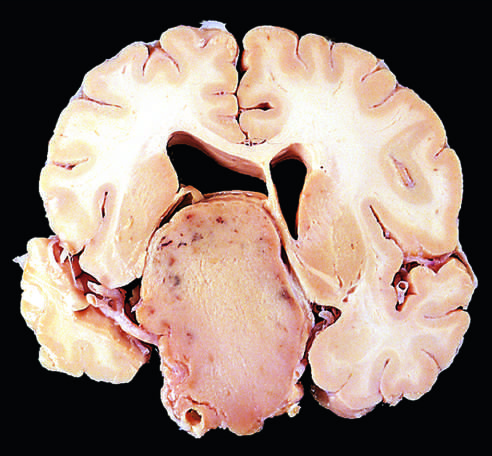do nonfunctioning adenomas tend to be larger at the time of diagnosis than those that secrete a hormone?
Answer the question using a single word or phrase. Yes 